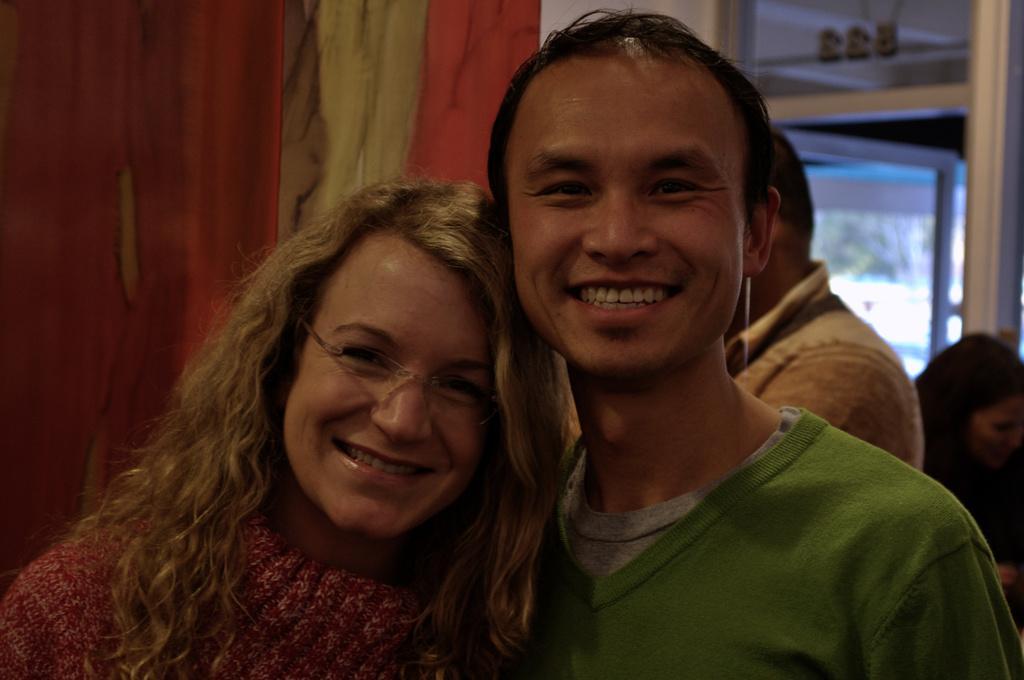In one or two sentences, can you explain what this image depicts? In front of the picture, we see a man and the women are standing. Both of them are smiling and they are posing for the photo. The woman is wearing the spectacles. Behind them, we see a man in the white shirt is standing. On the left side, we see a curtain or a sheet in red and white color. On the right side, we see the woman is sitting on the chair. Behind her, we see a glass door and a white wall. 